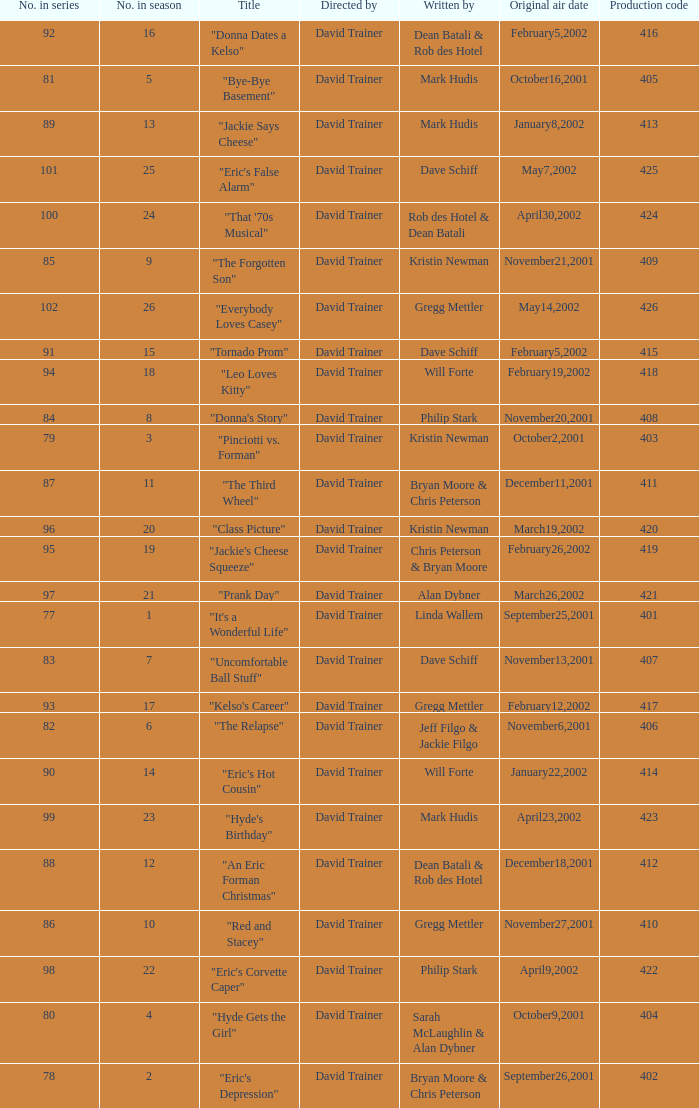How many production codes had a total number in the season of 8? 1.0. 